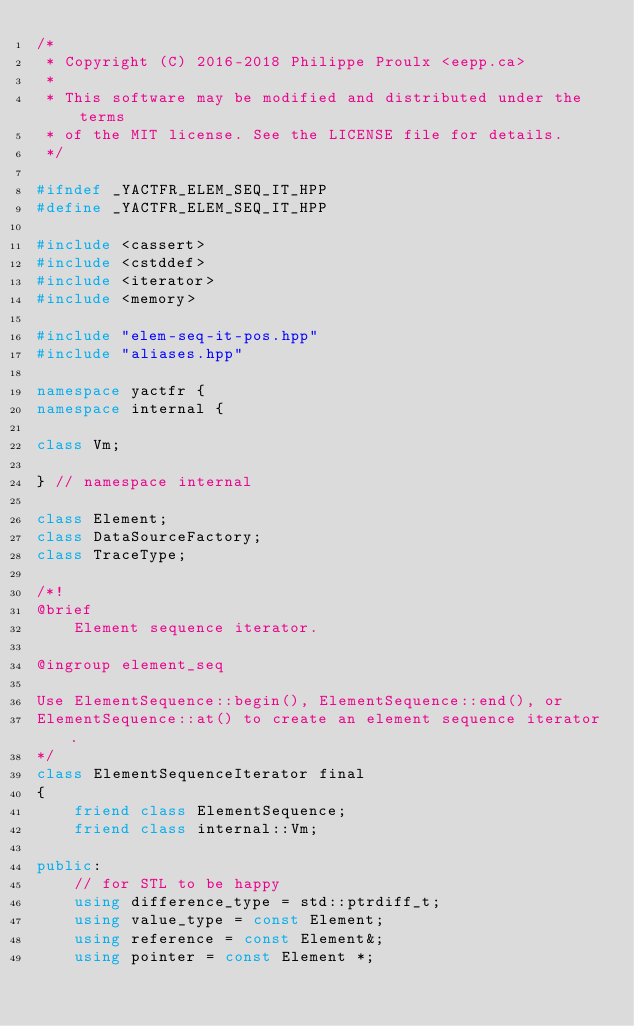<code> <loc_0><loc_0><loc_500><loc_500><_C++_>/*
 * Copyright (C) 2016-2018 Philippe Proulx <eepp.ca>
 *
 * This software may be modified and distributed under the terms
 * of the MIT license. See the LICENSE file for details.
 */

#ifndef _YACTFR_ELEM_SEQ_IT_HPP
#define _YACTFR_ELEM_SEQ_IT_HPP

#include <cassert>
#include <cstddef>
#include <iterator>
#include <memory>

#include "elem-seq-it-pos.hpp"
#include "aliases.hpp"

namespace yactfr {
namespace internal {

class Vm;

} // namespace internal

class Element;
class DataSourceFactory;
class TraceType;

/*!
@brief
    Element sequence iterator.

@ingroup element_seq

Use ElementSequence::begin(), ElementSequence::end(), or
ElementSequence::at() to create an element sequence iterator.
*/
class ElementSequenceIterator final
{
    friend class ElementSequence;
    friend class internal::Vm;

public:
    // for STL to be happy
    using difference_type = std::ptrdiff_t;
    using value_type = const Element;
    using reference = const Element&;
    using pointer = const Element *;</code> 